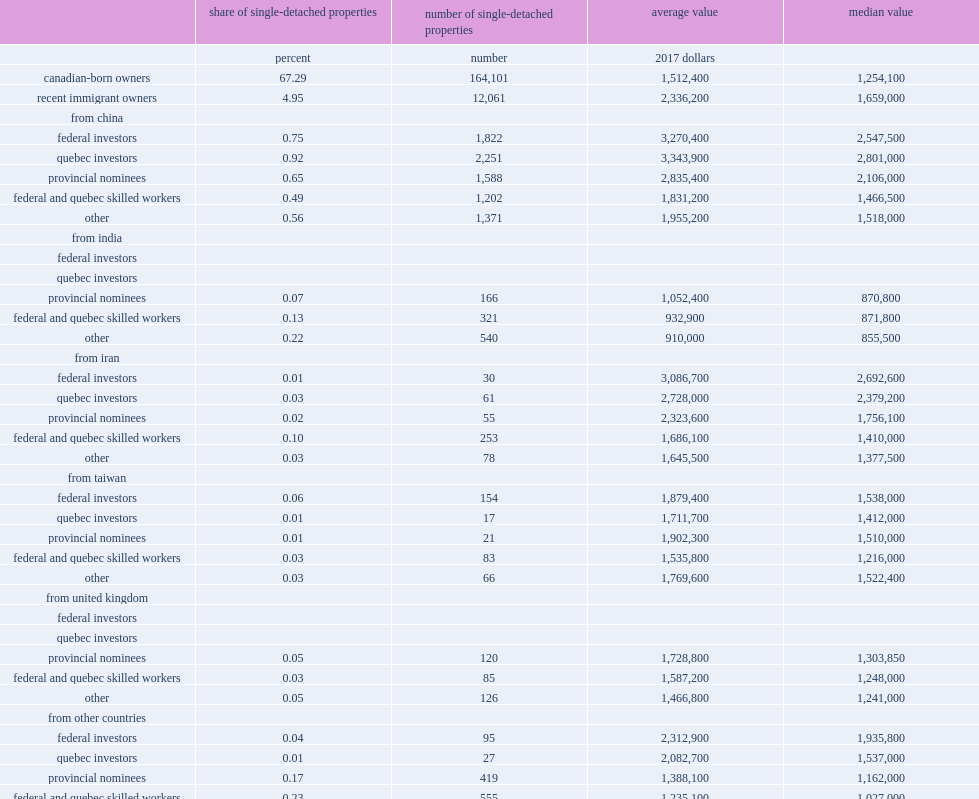What was the average value of single-detached properties owned by those coming from india among recent immigrants who came to canada under provincial nominee programs? 1052400.0. What was the average value of single-detached properties owned by those coming from china among recent immigrants who came to canada under provincial nominee programs? 2835400.0. What was the average value of single-detached properties owned by those coming from united kingdom among recent immigrants who came to canada under provincial nominee programs? 1728800.0. What was the average value of single-detached properties owned by those coming from india among recent immigrants coming under the federal and quebec skilled workers programs? 932900.0. What was the average value of single-detached properties owned by those coming from china among recent immigrants coming under the federal and quebec skilled workers programs? 1831200.0. What was the average value of single-detached properties owned by those coming from united kingdom among recent immigrants coming under the federal and quebec skilled workers programs? 1587200.0. 